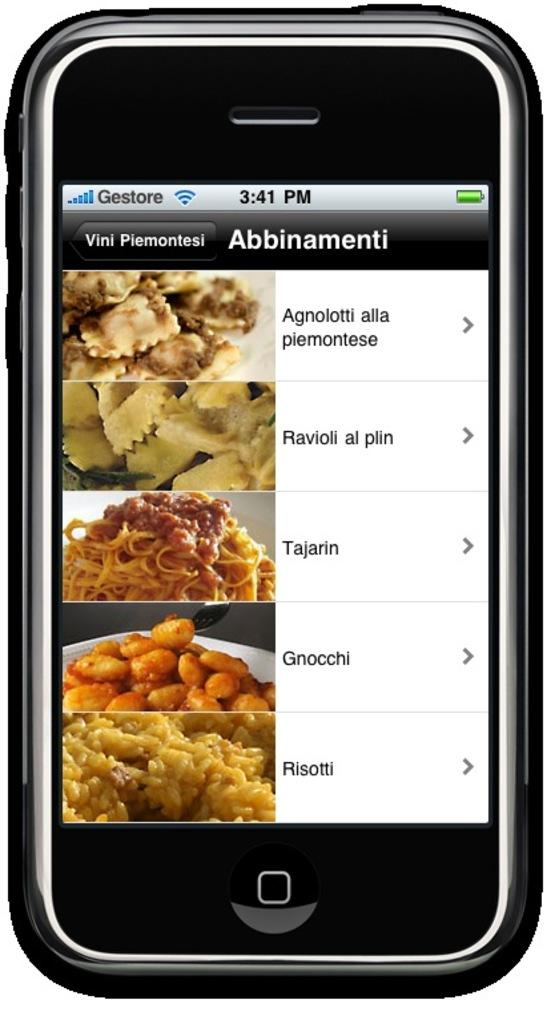What electronic device is visible in the image? There is a mobile phone in the image. What is on the screen of the mobile phone? There are food items on the mobile phone. Are there any labels or identifiers for the food items? Yes, there are names associated with the food items. What type of pipe is visible in the image? There is no pipe present in the image. How many fingers are touching the mobile phone in the image? There is no hand or fingers visible in the image, as it only shows the mobile phone with food items on the screen. 